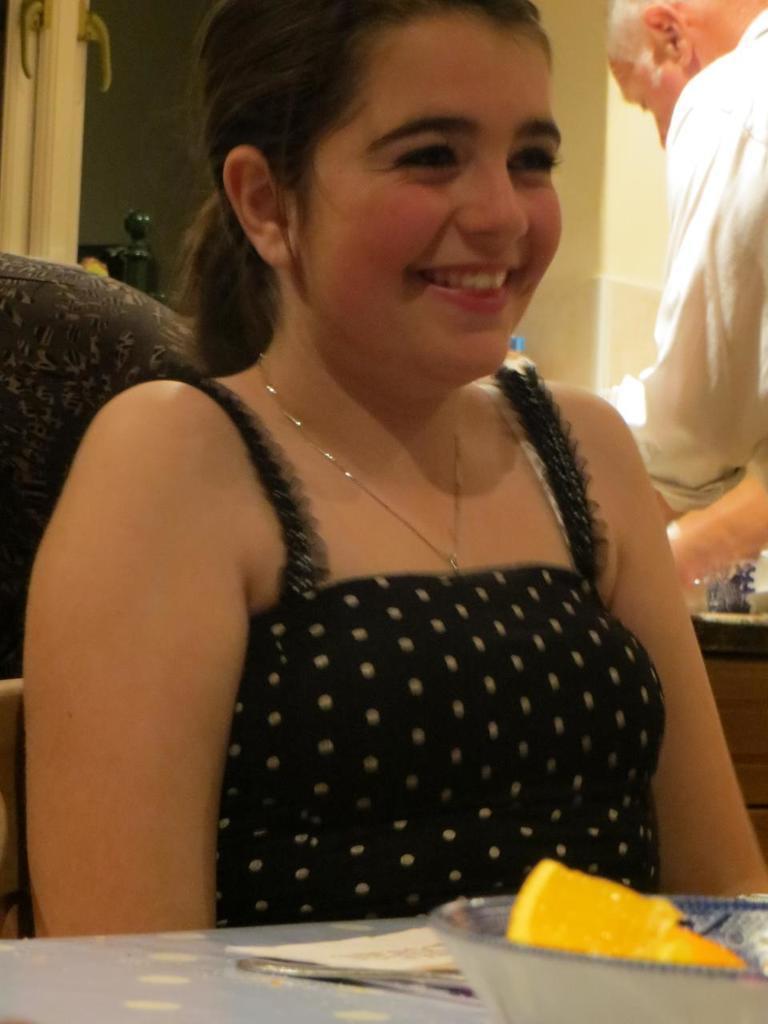In one or two sentences, can you explain what this image depicts? In this image we can see one woman with smiling face sitting on the chair near the table, one object near the woman on the left side of the image, one man in white shirt on the right side of the image, some objects on the left side of the image, some objects on the right side of the image, two objects in the background near the wall, one bowl with food and one object on the table. 